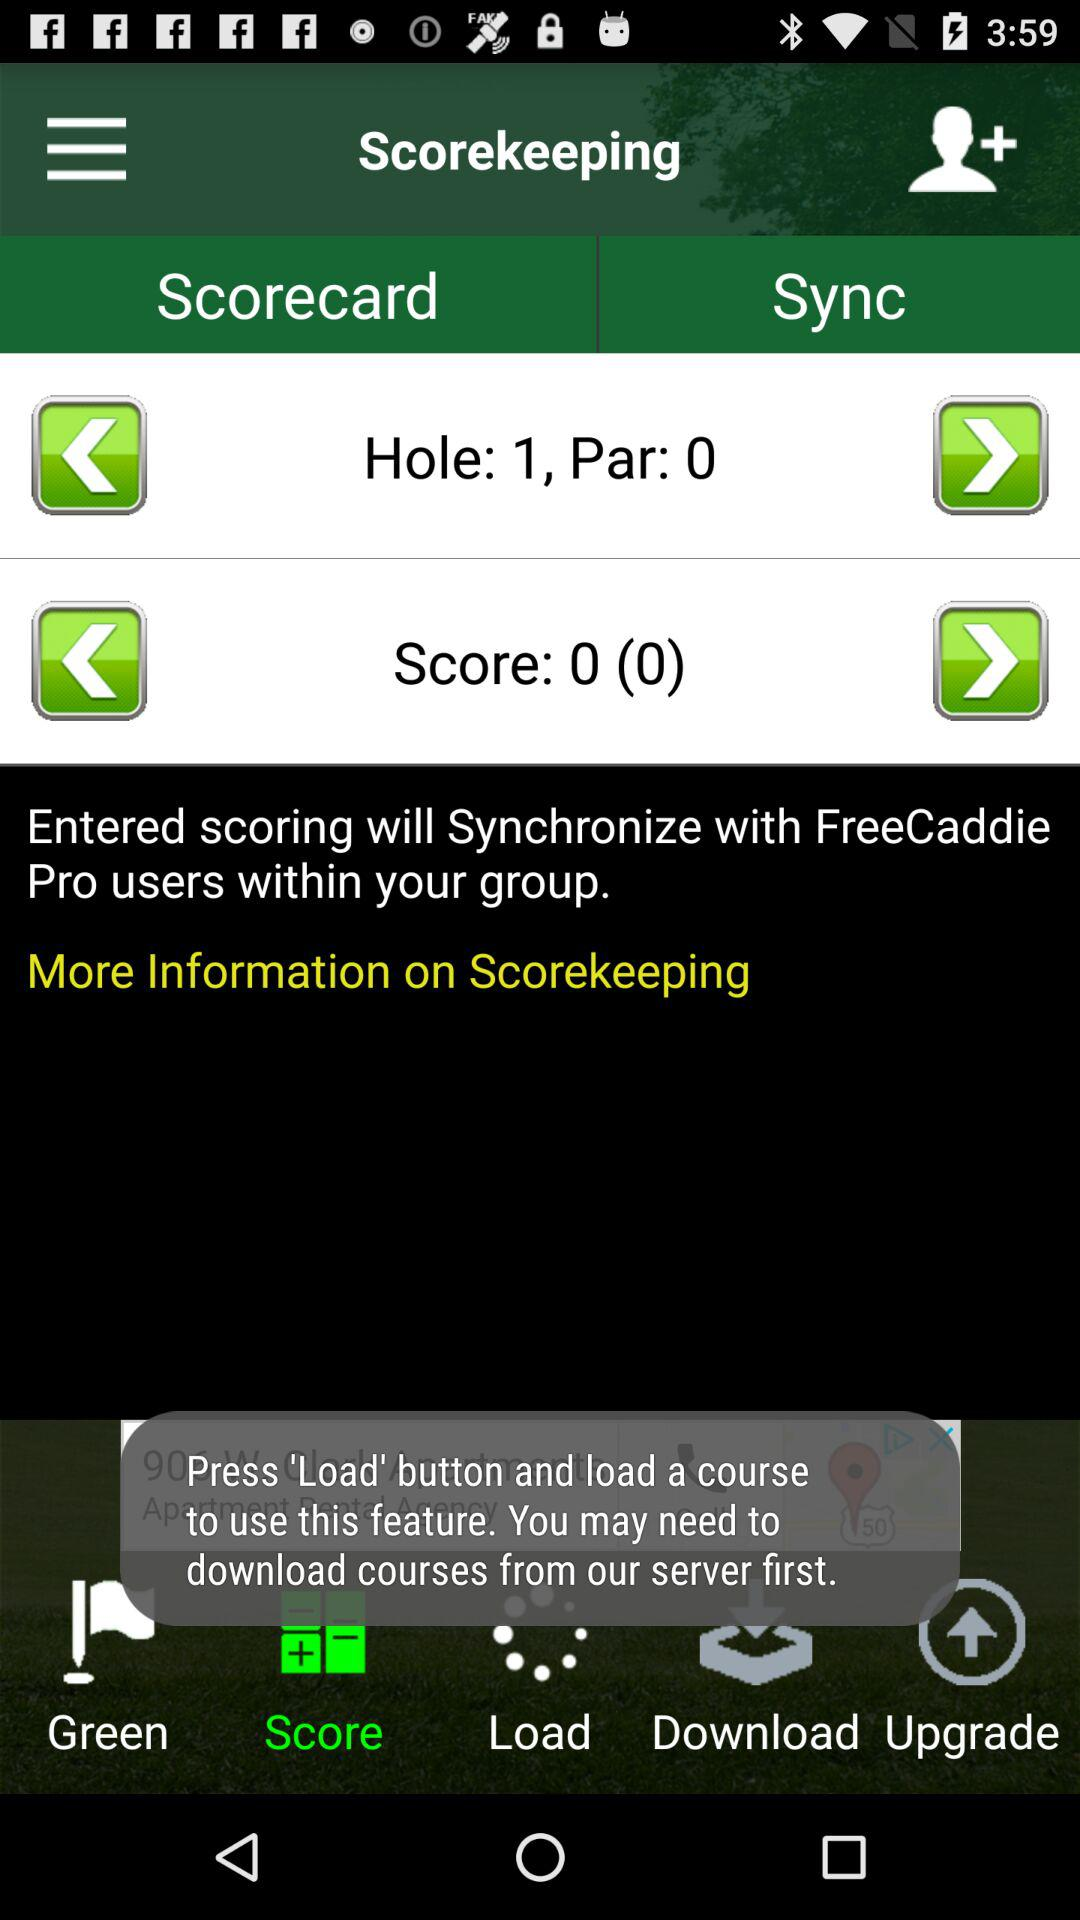Which tab is selected? The selected tab is "Score". 